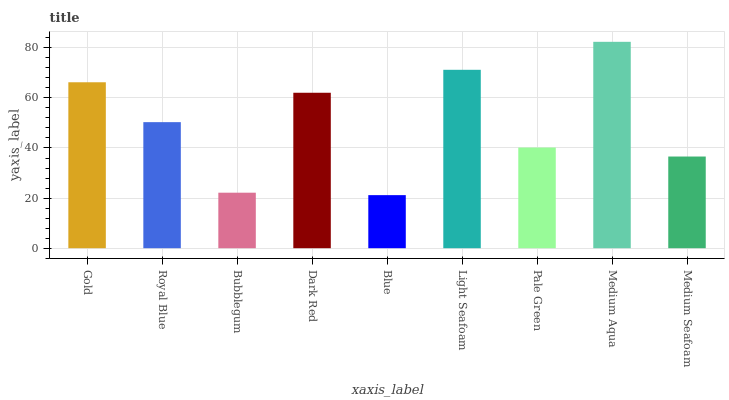Is Blue the minimum?
Answer yes or no. Yes. Is Medium Aqua the maximum?
Answer yes or no. Yes. Is Royal Blue the minimum?
Answer yes or no. No. Is Royal Blue the maximum?
Answer yes or no. No. Is Gold greater than Royal Blue?
Answer yes or no. Yes. Is Royal Blue less than Gold?
Answer yes or no. Yes. Is Royal Blue greater than Gold?
Answer yes or no. No. Is Gold less than Royal Blue?
Answer yes or no. No. Is Royal Blue the high median?
Answer yes or no. Yes. Is Royal Blue the low median?
Answer yes or no. Yes. Is Blue the high median?
Answer yes or no. No. Is Blue the low median?
Answer yes or no. No. 